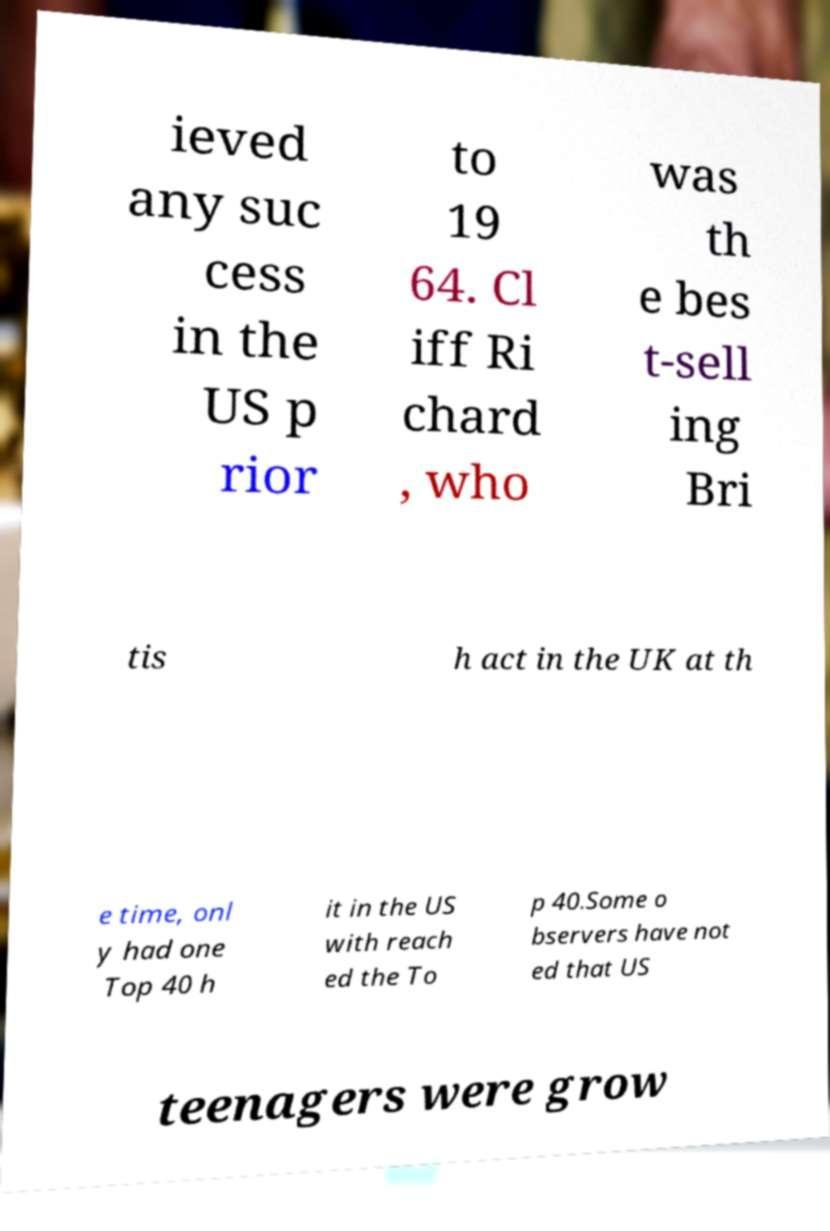Can you accurately transcribe the text from the provided image for me? ieved any suc cess in the US p rior to 19 64. Cl iff Ri chard , who was th e bes t-sell ing Bri tis h act in the UK at th e time, onl y had one Top 40 h it in the US with reach ed the To p 40.Some o bservers have not ed that US teenagers were grow 